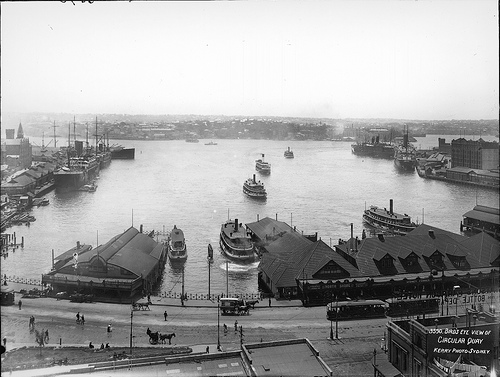Please transcribe the text in this image. CIRCULAR 